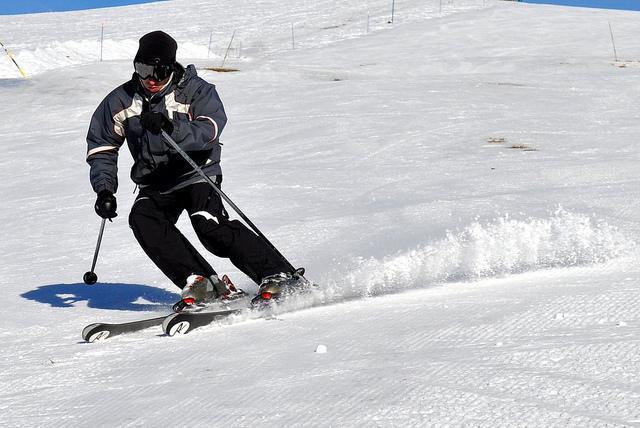How many poles?
Give a very brief answer. 2. How many vases are in the picture?
Give a very brief answer. 0. 